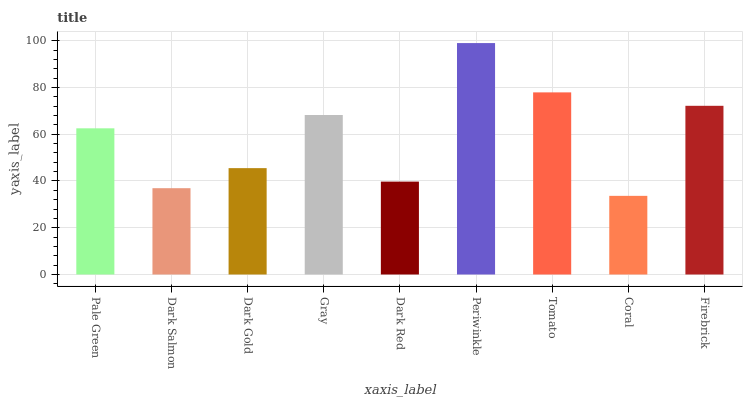Is Coral the minimum?
Answer yes or no. Yes. Is Periwinkle the maximum?
Answer yes or no. Yes. Is Dark Salmon the minimum?
Answer yes or no. No. Is Dark Salmon the maximum?
Answer yes or no. No. Is Pale Green greater than Dark Salmon?
Answer yes or no. Yes. Is Dark Salmon less than Pale Green?
Answer yes or no. Yes. Is Dark Salmon greater than Pale Green?
Answer yes or no. No. Is Pale Green less than Dark Salmon?
Answer yes or no. No. Is Pale Green the high median?
Answer yes or no. Yes. Is Pale Green the low median?
Answer yes or no. Yes. Is Periwinkle the high median?
Answer yes or no. No. Is Dark Gold the low median?
Answer yes or no. No. 